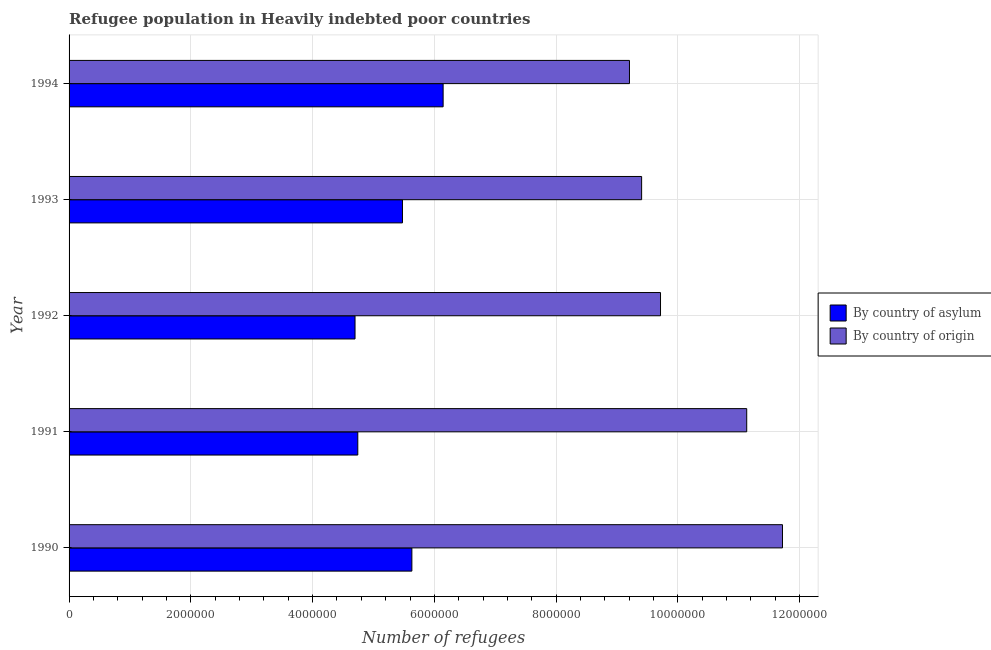How many different coloured bars are there?
Ensure brevity in your answer.  2. How many groups of bars are there?
Provide a succinct answer. 5. Are the number of bars per tick equal to the number of legend labels?
Make the answer very short. Yes. What is the label of the 2nd group of bars from the top?
Offer a terse response. 1993. What is the number of refugees by country of origin in 1994?
Give a very brief answer. 9.20e+06. Across all years, what is the maximum number of refugees by country of origin?
Ensure brevity in your answer.  1.17e+07. Across all years, what is the minimum number of refugees by country of asylum?
Your answer should be very brief. 4.70e+06. In which year was the number of refugees by country of asylum maximum?
Keep it short and to the point. 1994. In which year was the number of refugees by country of origin minimum?
Offer a terse response. 1994. What is the total number of refugees by country of asylum in the graph?
Provide a short and direct response. 2.67e+07. What is the difference between the number of refugees by country of asylum in 1990 and that in 1993?
Your answer should be very brief. 1.54e+05. What is the difference between the number of refugees by country of origin in 1991 and the number of refugees by country of asylum in 1992?
Your answer should be very brief. 6.43e+06. What is the average number of refugees by country of asylum per year?
Your answer should be compact. 5.34e+06. In the year 1993, what is the difference between the number of refugees by country of asylum and number of refugees by country of origin?
Offer a very short reply. -3.93e+06. What is the ratio of the number of refugees by country of origin in 1990 to that in 1991?
Make the answer very short. 1.05. Is the number of refugees by country of asylum in 1993 less than that in 1994?
Make the answer very short. Yes. Is the difference between the number of refugees by country of asylum in 1990 and 1992 greater than the difference between the number of refugees by country of origin in 1990 and 1992?
Your response must be concise. No. What is the difference between the highest and the second highest number of refugees by country of origin?
Offer a terse response. 5.87e+05. What is the difference between the highest and the lowest number of refugees by country of origin?
Offer a terse response. 2.51e+06. In how many years, is the number of refugees by country of origin greater than the average number of refugees by country of origin taken over all years?
Keep it short and to the point. 2. Is the sum of the number of refugees by country of asylum in 1990 and 1993 greater than the maximum number of refugees by country of origin across all years?
Provide a succinct answer. No. What does the 2nd bar from the top in 1990 represents?
Make the answer very short. By country of asylum. What does the 2nd bar from the bottom in 1990 represents?
Your answer should be compact. By country of origin. How many bars are there?
Ensure brevity in your answer.  10. How many years are there in the graph?
Provide a succinct answer. 5. Does the graph contain any zero values?
Offer a terse response. No. How many legend labels are there?
Offer a terse response. 2. How are the legend labels stacked?
Provide a succinct answer. Vertical. What is the title of the graph?
Your answer should be very brief. Refugee population in Heavily indebted poor countries. What is the label or title of the X-axis?
Make the answer very short. Number of refugees. What is the Number of refugees of By country of asylum in 1990?
Your response must be concise. 5.63e+06. What is the Number of refugees in By country of origin in 1990?
Your response must be concise. 1.17e+07. What is the Number of refugees in By country of asylum in 1991?
Your answer should be compact. 4.74e+06. What is the Number of refugees in By country of origin in 1991?
Give a very brief answer. 1.11e+07. What is the Number of refugees of By country of asylum in 1992?
Give a very brief answer. 4.70e+06. What is the Number of refugees of By country of origin in 1992?
Your response must be concise. 9.72e+06. What is the Number of refugees in By country of asylum in 1993?
Your answer should be very brief. 5.48e+06. What is the Number of refugees in By country of origin in 1993?
Offer a terse response. 9.40e+06. What is the Number of refugees in By country of asylum in 1994?
Your answer should be very brief. 6.14e+06. What is the Number of refugees in By country of origin in 1994?
Provide a succinct answer. 9.20e+06. Across all years, what is the maximum Number of refugees of By country of asylum?
Provide a short and direct response. 6.14e+06. Across all years, what is the maximum Number of refugees in By country of origin?
Give a very brief answer. 1.17e+07. Across all years, what is the minimum Number of refugees in By country of asylum?
Your answer should be very brief. 4.70e+06. Across all years, what is the minimum Number of refugees of By country of origin?
Provide a short and direct response. 9.20e+06. What is the total Number of refugees in By country of asylum in the graph?
Keep it short and to the point. 2.67e+07. What is the total Number of refugees in By country of origin in the graph?
Offer a terse response. 5.12e+07. What is the difference between the Number of refugees of By country of asylum in 1990 and that in 1991?
Ensure brevity in your answer.  8.88e+05. What is the difference between the Number of refugees of By country of origin in 1990 and that in 1991?
Ensure brevity in your answer.  5.87e+05. What is the difference between the Number of refugees of By country of asylum in 1990 and that in 1992?
Your response must be concise. 9.34e+05. What is the difference between the Number of refugees of By country of origin in 1990 and that in 1992?
Make the answer very short. 2.00e+06. What is the difference between the Number of refugees in By country of asylum in 1990 and that in 1993?
Ensure brevity in your answer.  1.54e+05. What is the difference between the Number of refugees of By country of origin in 1990 and that in 1993?
Offer a very short reply. 2.31e+06. What is the difference between the Number of refugees of By country of asylum in 1990 and that in 1994?
Your response must be concise. -5.14e+05. What is the difference between the Number of refugees in By country of origin in 1990 and that in 1994?
Make the answer very short. 2.51e+06. What is the difference between the Number of refugees in By country of asylum in 1991 and that in 1992?
Your answer should be compact. 4.54e+04. What is the difference between the Number of refugees of By country of origin in 1991 and that in 1992?
Give a very brief answer. 1.42e+06. What is the difference between the Number of refugees of By country of asylum in 1991 and that in 1993?
Keep it short and to the point. -7.34e+05. What is the difference between the Number of refugees in By country of origin in 1991 and that in 1993?
Your response must be concise. 1.73e+06. What is the difference between the Number of refugees of By country of asylum in 1991 and that in 1994?
Offer a very short reply. -1.40e+06. What is the difference between the Number of refugees of By country of origin in 1991 and that in 1994?
Provide a succinct answer. 1.93e+06. What is the difference between the Number of refugees of By country of asylum in 1992 and that in 1993?
Your answer should be very brief. -7.79e+05. What is the difference between the Number of refugees of By country of origin in 1992 and that in 1993?
Provide a short and direct response. 3.10e+05. What is the difference between the Number of refugees of By country of asylum in 1992 and that in 1994?
Give a very brief answer. -1.45e+06. What is the difference between the Number of refugees of By country of origin in 1992 and that in 1994?
Provide a short and direct response. 5.10e+05. What is the difference between the Number of refugees in By country of asylum in 1993 and that in 1994?
Keep it short and to the point. -6.68e+05. What is the difference between the Number of refugees in By country of origin in 1993 and that in 1994?
Make the answer very short. 2.00e+05. What is the difference between the Number of refugees in By country of asylum in 1990 and the Number of refugees in By country of origin in 1991?
Offer a very short reply. -5.50e+06. What is the difference between the Number of refugees in By country of asylum in 1990 and the Number of refugees in By country of origin in 1992?
Your response must be concise. -4.08e+06. What is the difference between the Number of refugees of By country of asylum in 1990 and the Number of refugees of By country of origin in 1993?
Give a very brief answer. -3.77e+06. What is the difference between the Number of refugees in By country of asylum in 1990 and the Number of refugees in By country of origin in 1994?
Offer a terse response. -3.57e+06. What is the difference between the Number of refugees in By country of asylum in 1991 and the Number of refugees in By country of origin in 1992?
Offer a very short reply. -4.97e+06. What is the difference between the Number of refugees of By country of asylum in 1991 and the Number of refugees of By country of origin in 1993?
Provide a short and direct response. -4.66e+06. What is the difference between the Number of refugees in By country of asylum in 1991 and the Number of refugees in By country of origin in 1994?
Keep it short and to the point. -4.46e+06. What is the difference between the Number of refugees of By country of asylum in 1992 and the Number of refugees of By country of origin in 1993?
Provide a short and direct response. -4.71e+06. What is the difference between the Number of refugees in By country of asylum in 1992 and the Number of refugees in By country of origin in 1994?
Your response must be concise. -4.51e+06. What is the difference between the Number of refugees of By country of asylum in 1993 and the Number of refugees of By country of origin in 1994?
Ensure brevity in your answer.  -3.73e+06. What is the average Number of refugees in By country of asylum per year?
Offer a very short reply. 5.34e+06. What is the average Number of refugees of By country of origin per year?
Provide a short and direct response. 1.02e+07. In the year 1990, what is the difference between the Number of refugees of By country of asylum and Number of refugees of By country of origin?
Make the answer very short. -6.09e+06. In the year 1991, what is the difference between the Number of refugees of By country of asylum and Number of refugees of By country of origin?
Your response must be concise. -6.39e+06. In the year 1992, what is the difference between the Number of refugees in By country of asylum and Number of refugees in By country of origin?
Your response must be concise. -5.02e+06. In the year 1993, what is the difference between the Number of refugees of By country of asylum and Number of refugees of By country of origin?
Keep it short and to the point. -3.93e+06. In the year 1994, what is the difference between the Number of refugees in By country of asylum and Number of refugees in By country of origin?
Make the answer very short. -3.06e+06. What is the ratio of the Number of refugees of By country of asylum in 1990 to that in 1991?
Ensure brevity in your answer.  1.19. What is the ratio of the Number of refugees of By country of origin in 1990 to that in 1991?
Provide a short and direct response. 1.05. What is the ratio of the Number of refugees of By country of asylum in 1990 to that in 1992?
Offer a very short reply. 1.2. What is the ratio of the Number of refugees of By country of origin in 1990 to that in 1992?
Keep it short and to the point. 1.21. What is the ratio of the Number of refugees in By country of asylum in 1990 to that in 1993?
Provide a short and direct response. 1.03. What is the ratio of the Number of refugees in By country of origin in 1990 to that in 1993?
Provide a succinct answer. 1.25. What is the ratio of the Number of refugees in By country of asylum in 1990 to that in 1994?
Keep it short and to the point. 0.92. What is the ratio of the Number of refugees in By country of origin in 1990 to that in 1994?
Provide a short and direct response. 1.27. What is the ratio of the Number of refugees of By country of asylum in 1991 to that in 1992?
Your answer should be compact. 1.01. What is the ratio of the Number of refugees of By country of origin in 1991 to that in 1992?
Make the answer very short. 1.15. What is the ratio of the Number of refugees in By country of asylum in 1991 to that in 1993?
Offer a terse response. 0.87. What is the ratio of the Number of refugees of By country of origin in 1991 to that in 1993?
Provide a succinct answer. 1.18. What is the ratio of the Number of refugees of By country of asylum in 1991 to that in 1994?
Keep it short and to the point. 0.77. What is the ratio of the Number of refugees of By country of origin in 1991 to that in 1994?
Offer a very short reply. 1.21. What is the ratio of the Number of refugees in By country of asylum in 1992 to that in 1993?
Offer a terse response. 0.86. What is the ratio of the Number of refugees of By country of origin in 1992 to that in 1993?
Provide a short and direct response. 1.03. What is the ratio of the Number of refugees in By country of asylum in 1992 to that in 1994?
Your response must be concise. 0.76. What is the ratio of the Number of refugees in By country of origin in 1992 to that in 1994?
Offer a very short reply. 1.06. What is the ratio of the Number of refugees in By country of asylum in 1993 to that in 1994?
Your response must be concise. 0.89. What is the ratio of the Number of refugees of By country of origin in 1993 to that in 1994?
Offer a terse response. 1.02. What is the difference between the highest and the second highest Number of refugees of By country of asylum?
Make the answer very short. 5.14e+05. What is the difference between the highest and the second highest Number of refugees of By country of origin?
Offer a terse response. 5.87e+05. What is the difference between the highest and the lowest Number of refugees in By country of asylum?
Provide a succinct answer. 1.45e+06. What is the difference between the highest and the lowest Number of refugees of By country of origin?
Provide a succinct answer. 2.51e+06. 